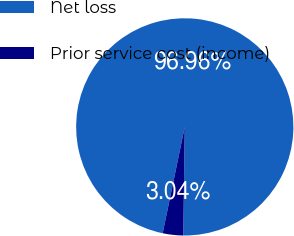Convert chart. <chart><loc_0><loc_0><loc_500><loc_500><pie_chart><fcel>Net loss<fcel>Prior service cost (income)<nl><fcel>96.96%<fcel>3.04%<nl></chart> 